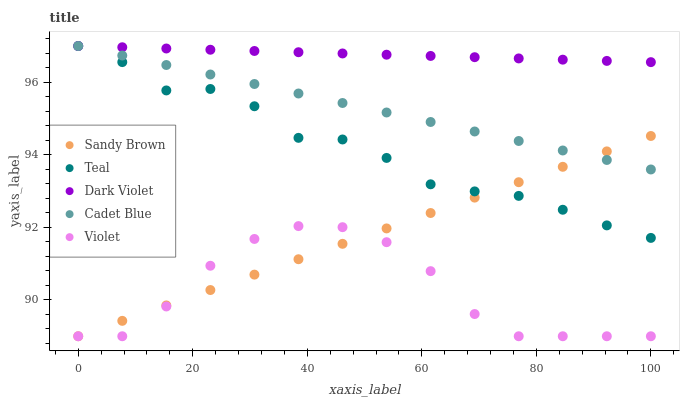Does Violet have the minimum area under the curve?
Answer yes or no. Yes. Does Dark Violet have the maximum area under the curve?
Answer yes or no. Yes. Does Sandy Brown have the minimum area under the curve?
Answer yes or no. No. Does Sandy Brown have the maximum area under the curve?
Answer yes or no. No. Is Dark Violet the smoothest?
Answer yes or no. Yes. Is Violet the roughest?
Answer yes or no. Yes. Is Sandy Brown the smoothest?
Answer yes or no. No. Is Sandy Brown the roughest?
Answer yes or no. No. Does Sandy Brown have the lowest value?
Answer yes or no. Yes. Does Dark Violet have the lowest value?
Answer yes or no. No. Does Teal have the highest value?
Answer yes or no. Yes. Does Sandy Brown have the highest value?
Answer yes or no. No. Is Sandy Brown less than Dark Violet?
Answer yes or no. Yes. Is Dark Violet greater than Sandy Brown?
Answer yes or no. Yes. Does Dark Violet intersect Teal?
Answer yes or no. Yes. Is Dark Violet less than Teal?
Answer yes or no. No. Is Dark Violet greater than Teal?
Answer yes or no. No. Does Sandy Brown intersect Dark Violet?
Answer yes or no. No. 